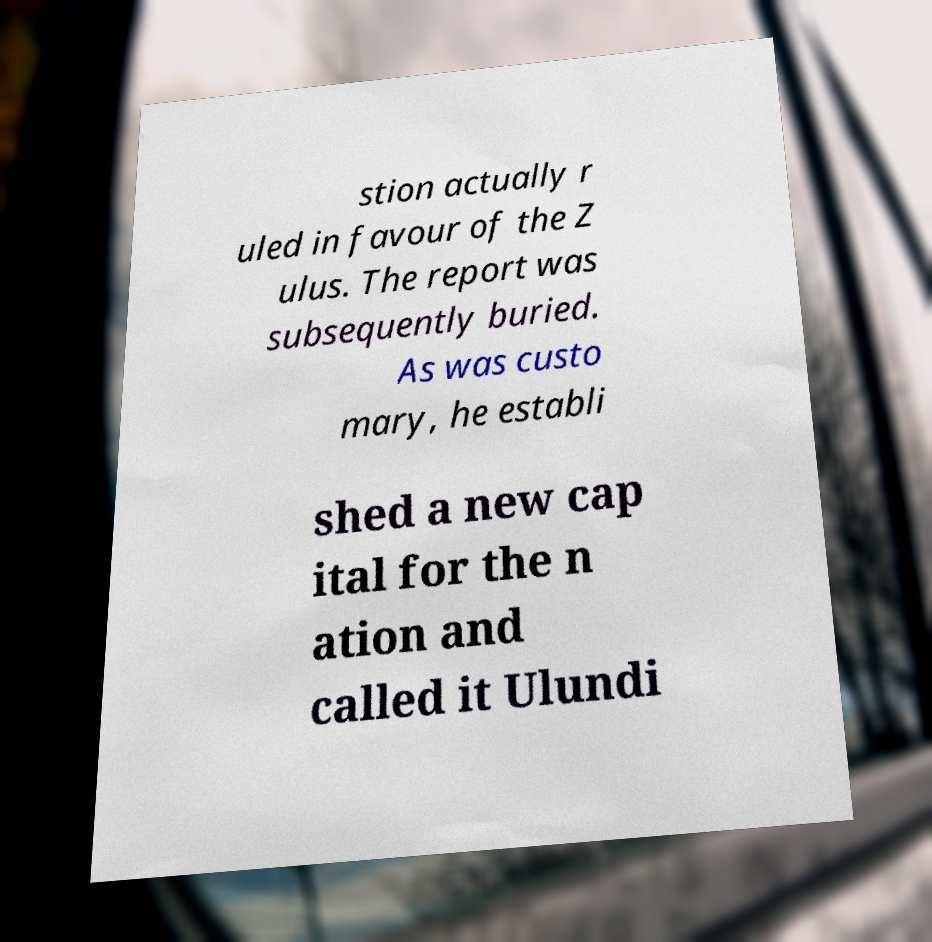Can you accurately transcribe the text from the provided image for me? stion actually r uled in favour of the Z ulus. The report was subsequently buried. As was custo mary, he establi shed a new cap ital for the n ation and called it Ulundi 